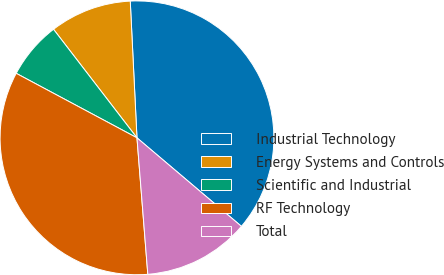Convert chart to OTSL. <chart><loc_0><loc_0><loc_500><loc_500><pie_chart><fcel>Industrial Technology<fcel>Energy Systems and Controls<fcel>Scientific and Industrial<fcel>RF Technology<fcel>Total<nl><fcel>36.97%<fcel>9.65%<fcel>6.76%<fcel>34.07%<fcel>12.55%<nl></chart> 